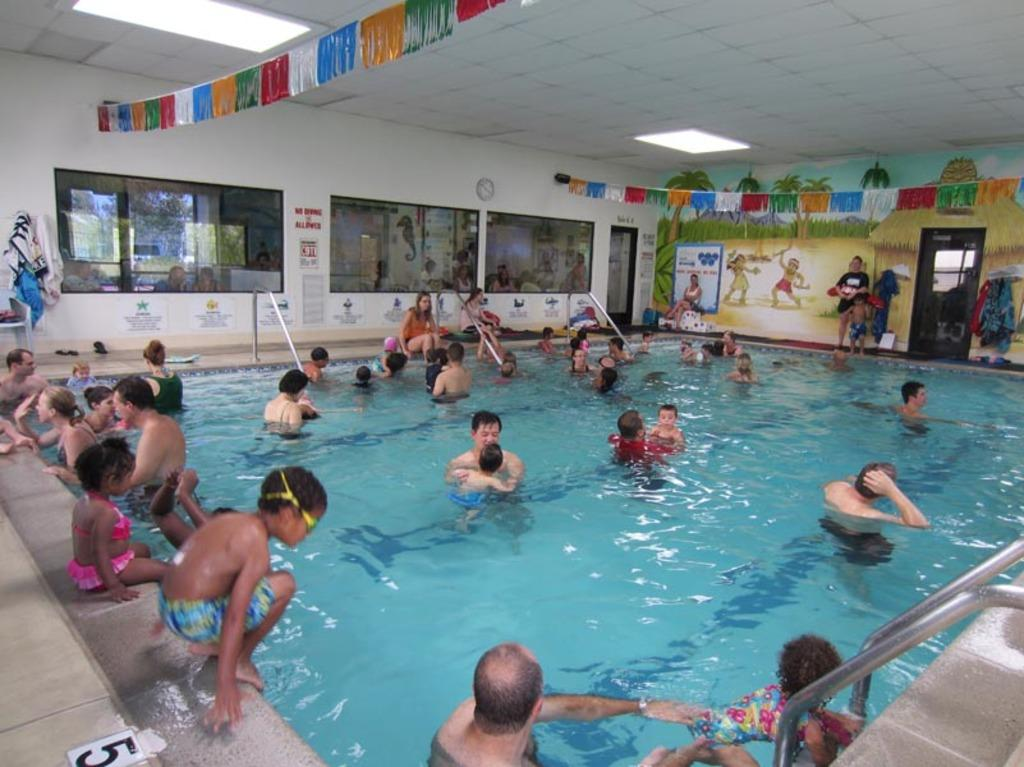Who is present in the image? There are kids and adults in the image. What are the people in the image doing? The people are swimming. Where is the swimming taking place? The swimming is taking place inside an indoor swimming pool. What type of pan can be seen on the head of the cat in the image? There is no cat or pan present in the image; it features kids and adults swimming in an indoor pool. 